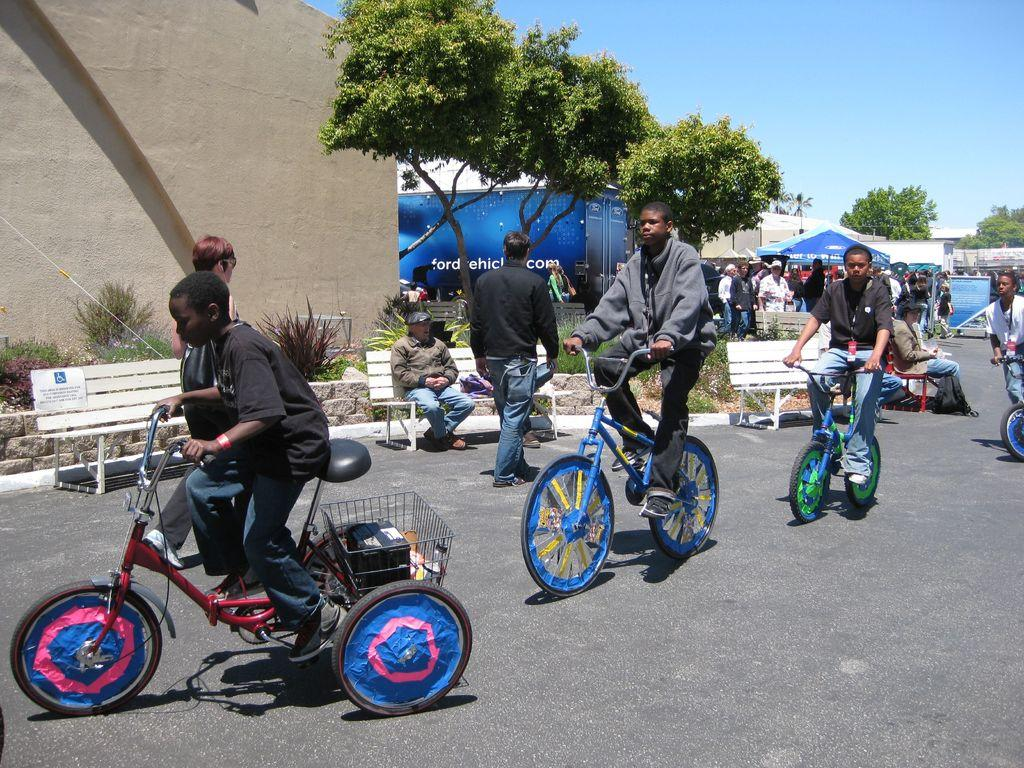What are the people in the image doing? The people in the image are riding bicycles on the road. Can you describe the background of the image? In the background, there are people, a wall, a building, trees, tents, a hoarding, and the sky. How many different structures or objects can be seen in the background? There are at least eight different structures or objects visible in the background: people, a wall, a building, trees, tents, a hoarding, and the sky. What type of water activity is the father participating in with his children in the image? There is no water activity or father present in the image; it features people riding bicycles on the road and a background with various structures and objects. How many medals did the winner of the competition receive in the image? There is no competition or winner present in the image; it features people riding bicycles on the road and a background with various structures and objects. 